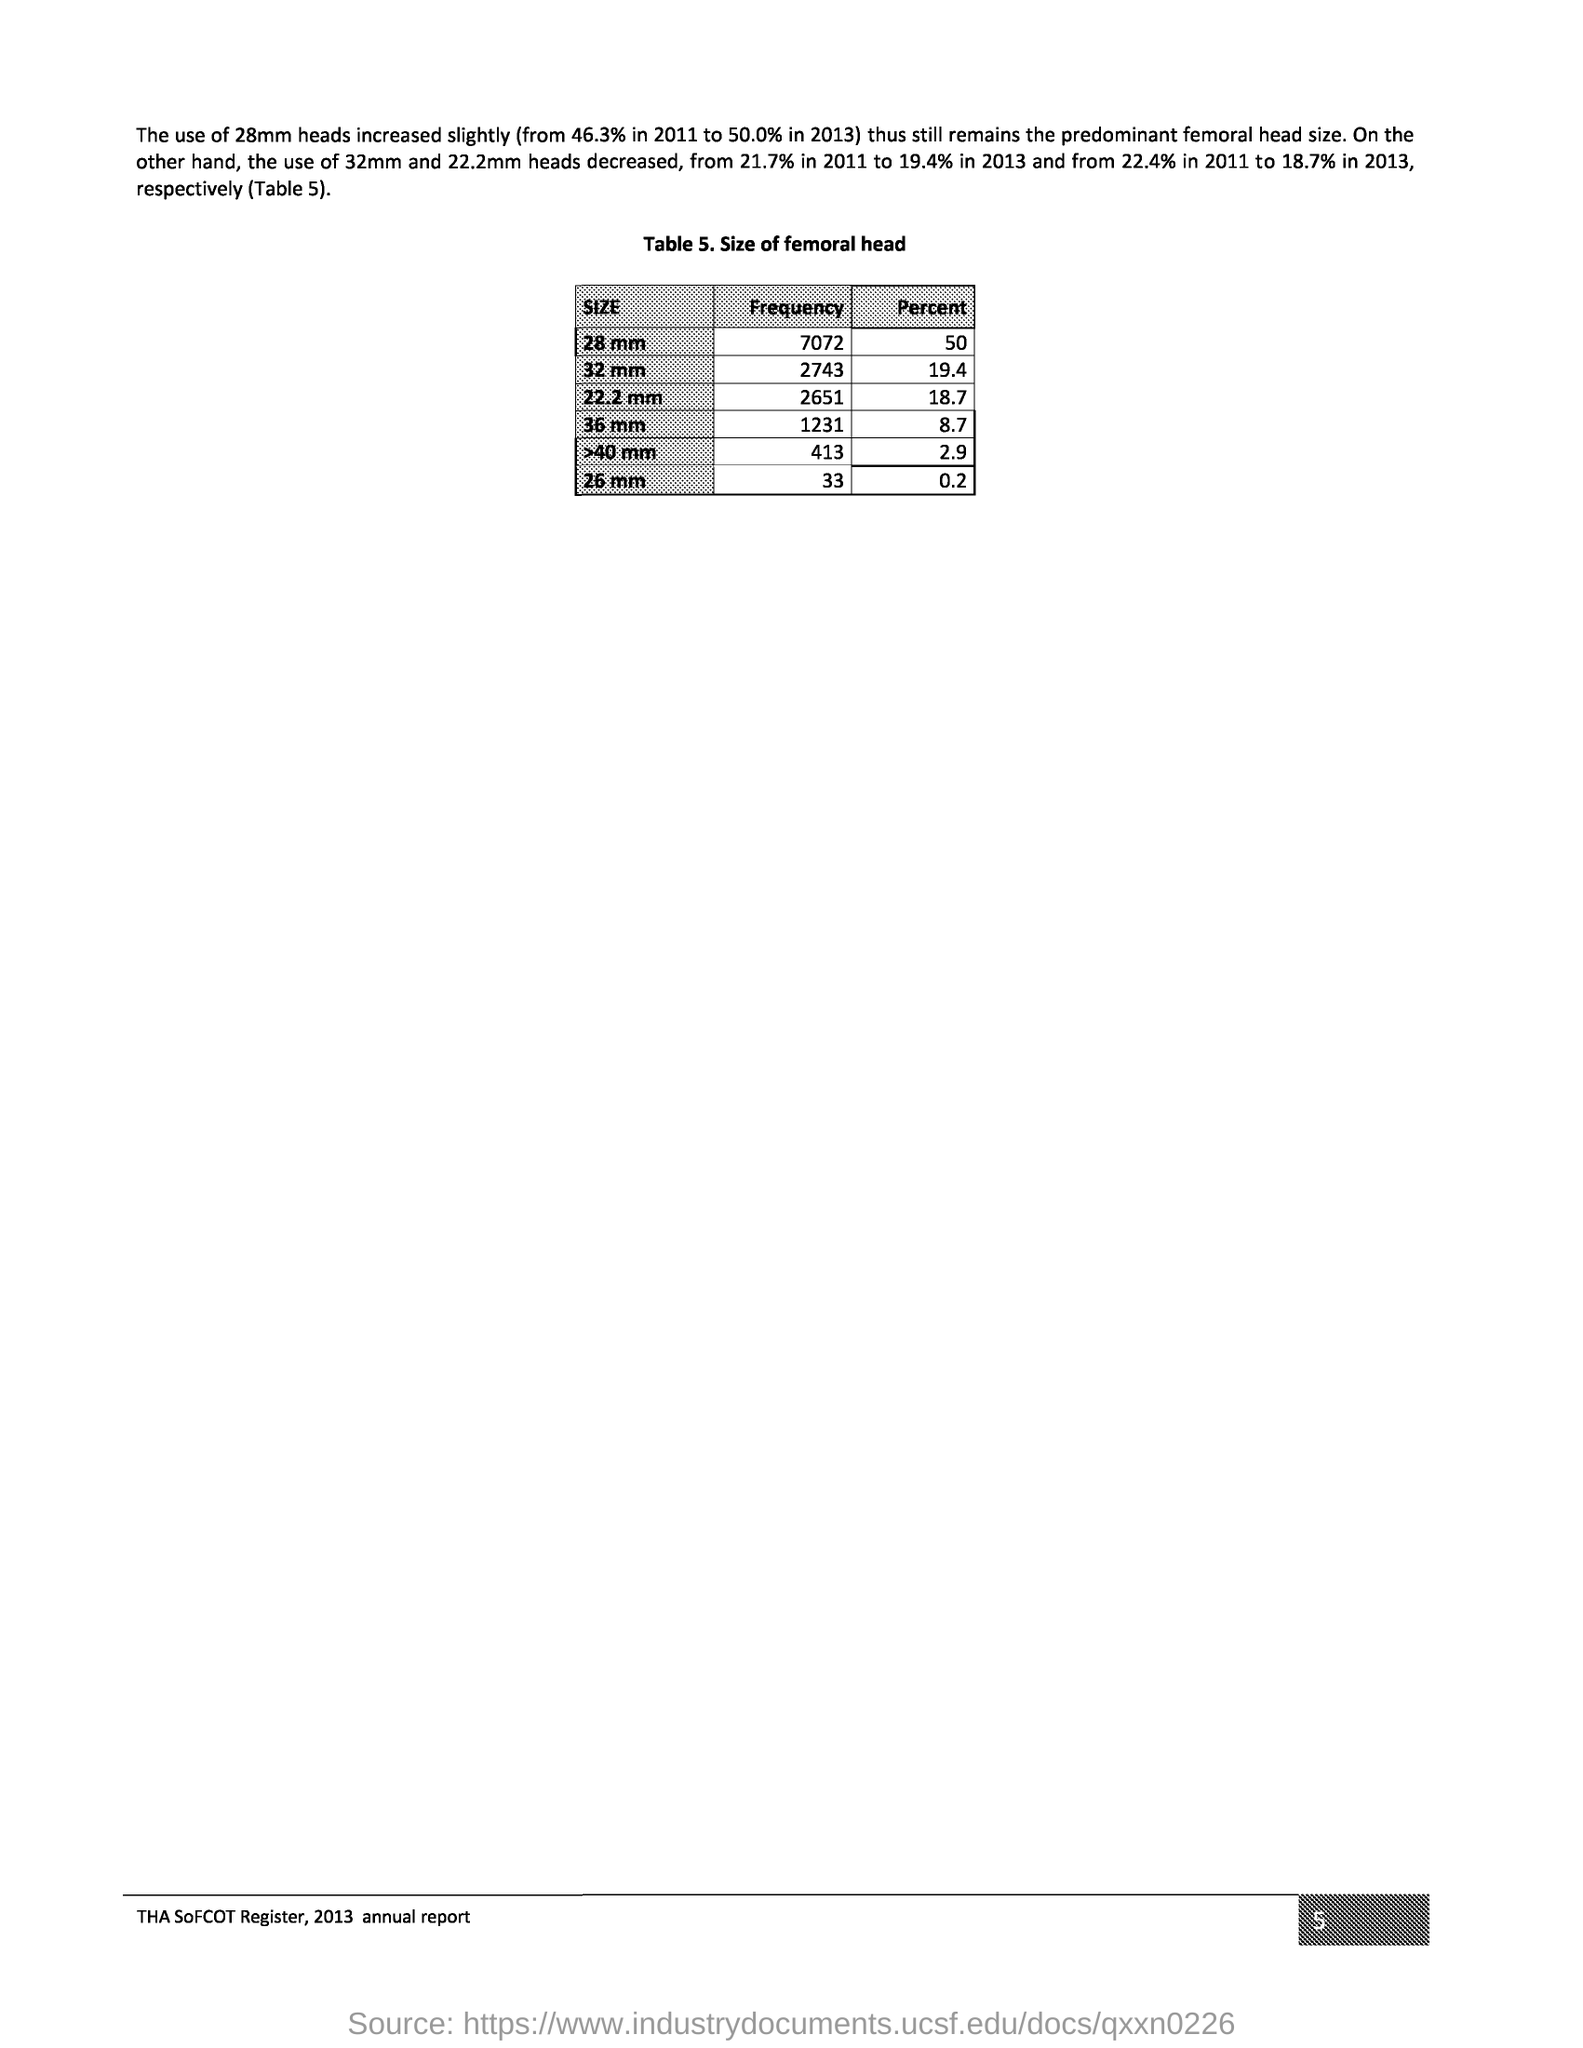Highlight a few significant elements in this photo. Table 5 represents the size of the femoral head. The page number mentioned in this document is 5. 